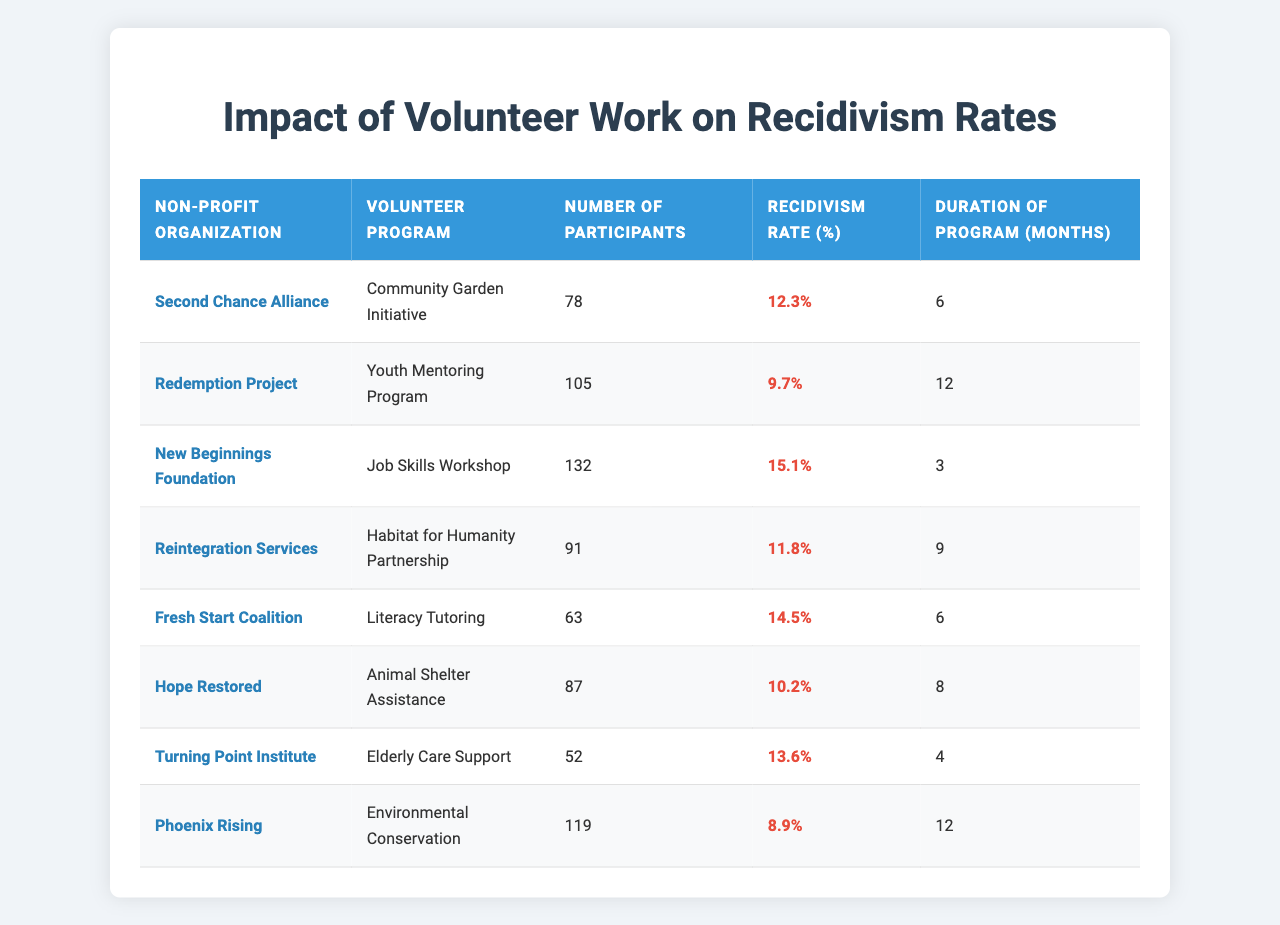What is the recidivism rate for the Youth Mentoring Program? The recidivism rate is explicitly listed in the table next to the "Youth Mentoring Program" under the "Recidivism Rate (%)" column, which shows 9.7%.
Answer: 9.7% How many participants joined the Community Garden Initiative? The number of participants is found in the table next to the "Community Garden Initiative" under the "Number of Participants" column, showing 78 participants.
Answer: 78 Which volunteer program has the highest recidivism rate? To find the highest recidivism rate, we compare all the rates in the "Recidivism Rate (%)" column. The highest rate is 15.1% for the Job Skills Workshop.
Answer: Job Skills Workshop What is the average recidivism rate of all the programs listed? First, we add all the recidivism rates: 12.3 + 9.7 + 15.1 + 11.8 + 14.5 + 10.2 + 13.6 + 8.9 = 96.1%. Then, we divide by the number of programs (8), which gives us an average of 12.01%.
Answer: 12.01% Is the recidivism rate for the Animal Shelter Assistance program less than 15%? The recidivism rate for the Animal Shelter Assistance program is listed as 10.2%, which is indeed less than 15%.
Answer: Yes Which program had the shortest duration and what was its recidivism rate? The duration of the programs is found in the "Duration of Program (months)" column. The shortest duration is 3 months for the Job Skills Workshop, with a recidivism rate of 15.1%.
Answer: Job Skills Workshop, 15.1% If we combined the participants from both the Community Garden Initiative and Literacy Tutoring programs, how many would that be? We sum the participants from both programs: 78 (Community Garden Initiative) + 63 (Literacy Tutoring) = 141 participants.
Answer: 141 Is there a program with a recidivism rate below 10%? Checking the "Recidivism Rate (%)" column, the lowest rate is 8.9% for the Environmental Conservation, indicating there is indeed a program with a rate below 10%.
Answer: Yes What is the difference in recidivism rates between the Job Skills Workshop and the Environmental Conservation program? The recidivism rate for the Job Skills Workshop is 15.1%, and for the Environmental Conservation program, it is 8.9%. The difference is calculated as 15.1 - 8.9 = 6.2%.
Answer: 6.2% Are there more participants in the Youth Mentoring Program than the Literacy Tutoring program? The Youth Mentoring Program has 105 participants and the Literacy Tutoring program has 63 participants. Since 105 is greater than 63, the answer is yes.
Answer: Yes 